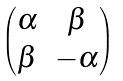Convert formula to latex. <formula><loc_0><loc_0><loc_500><loc_500>\begin{pmatrix} \alpha & \beta \\ \beta & - \alpha \end{pmatrix}</formula> 